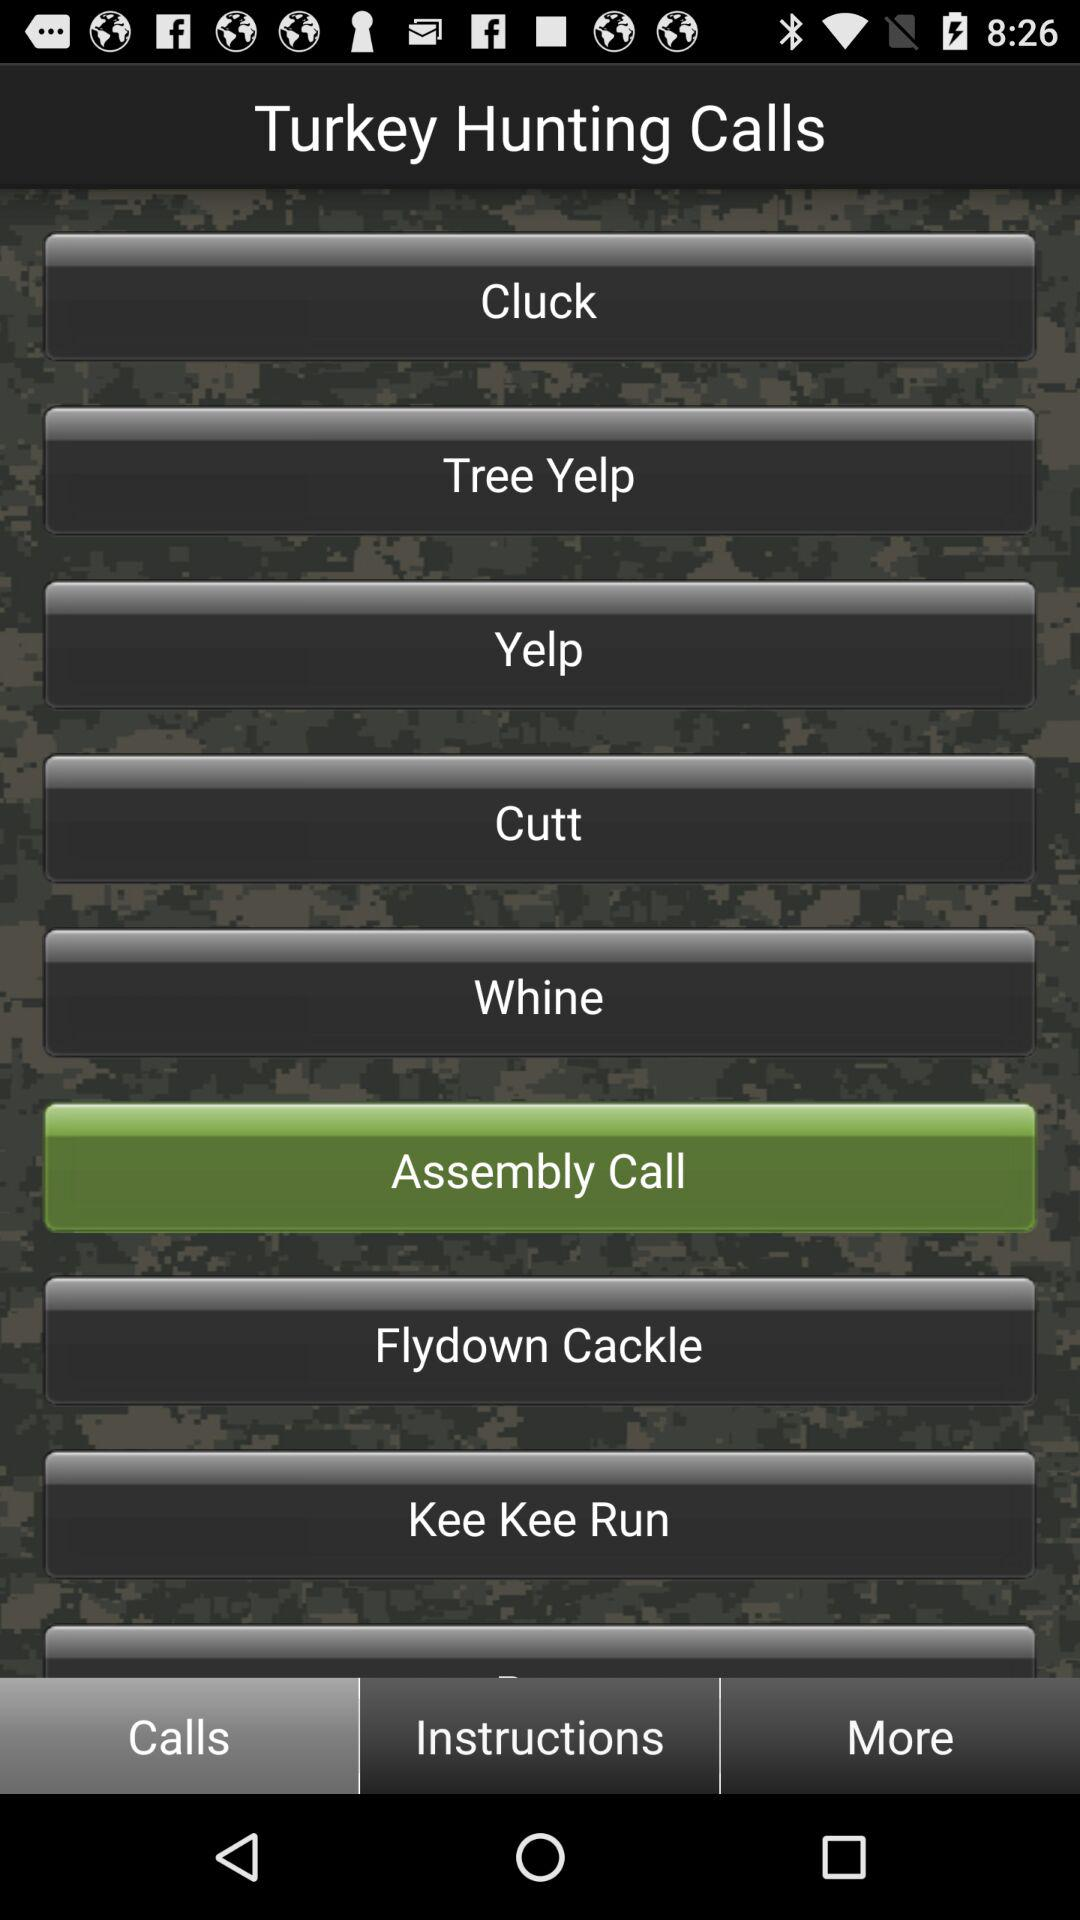Which tab is selected? The selected tab is "Calls". 